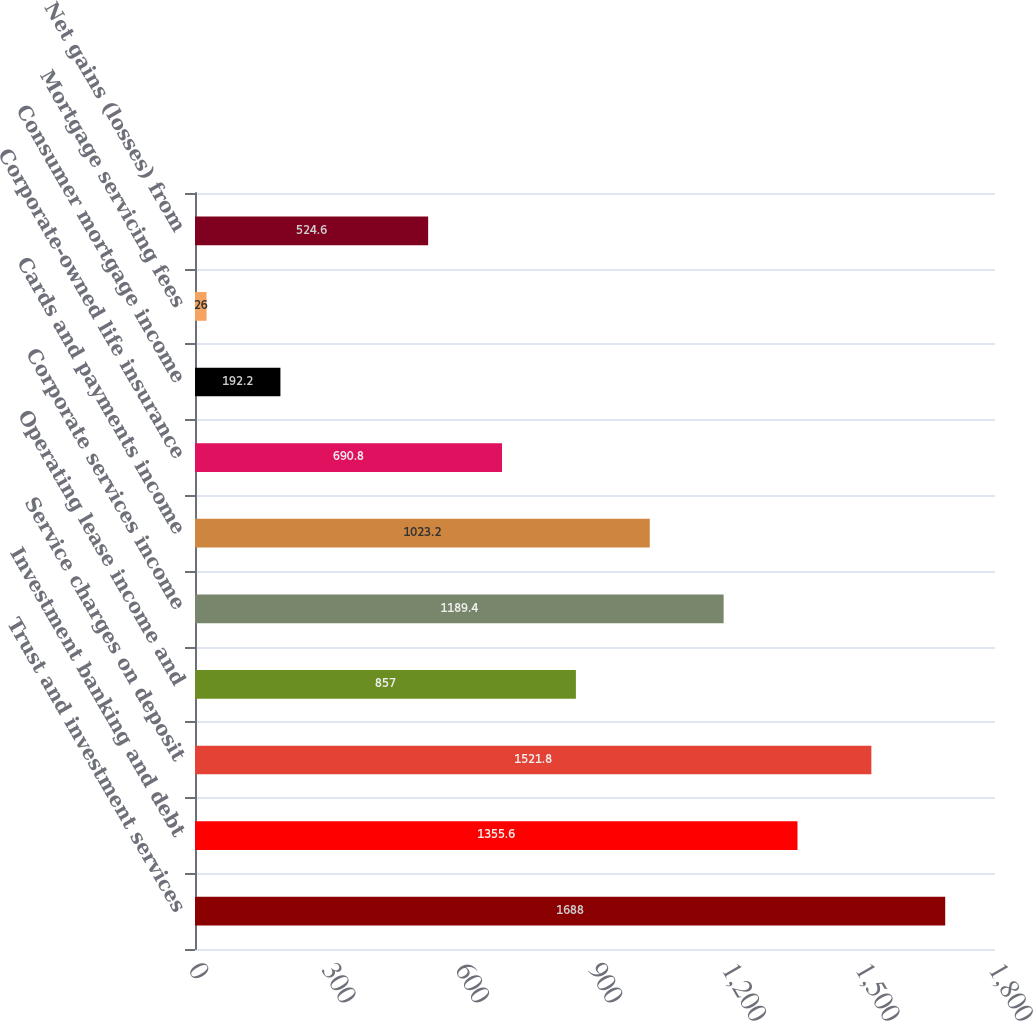Convert chart. <chart><loc_0><loc_0><loc_500><loc_500><bar_chart><fcel>Trust and investment services<fcel>Investment banking and debt<fcel>Service charges on deposit<fcel>Operating lease income and<fcel>Corporate services income<fcel>Cards and payments income<fcel>Corporate-owned life insurance<fcel>Consumer mortgage income<fcel>Mortgage servicing fees<fcel>Net gains (losses) from<nl><fcel>1688<fcel>1355.6<fcel>1521.8<fcel>857<fcel>1189.4<fcel>1023.2<fcel>690.8<fcel>192.2<fcel>26<fcel>524.6<nl></chart> 